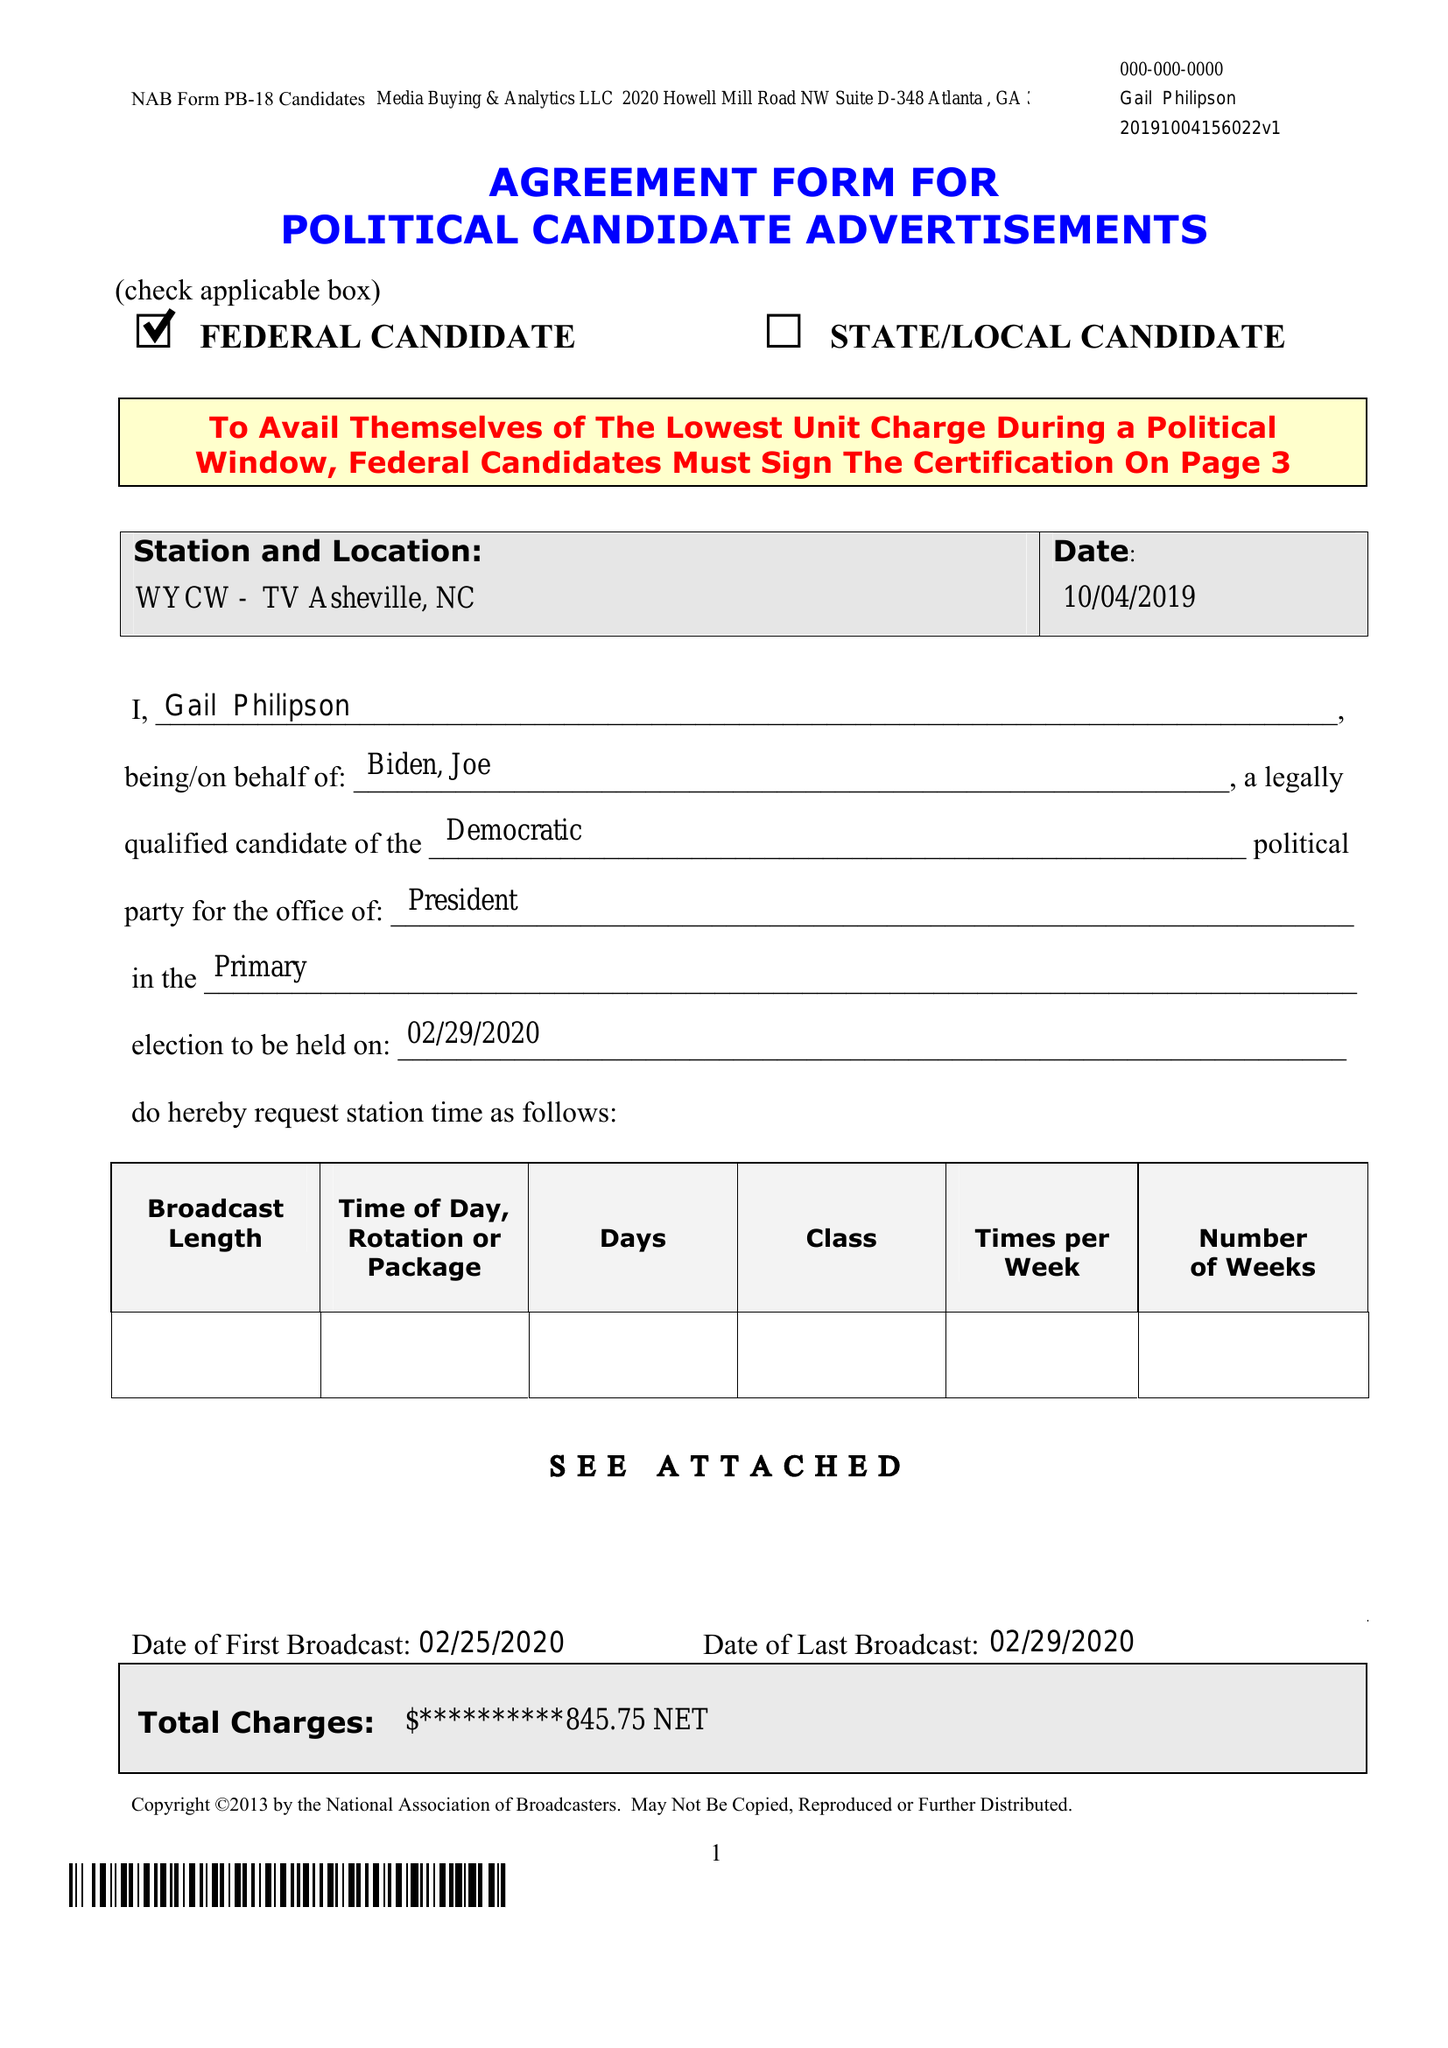What is the value for the contract_num?
Answer the question using a single word or phrase. None 